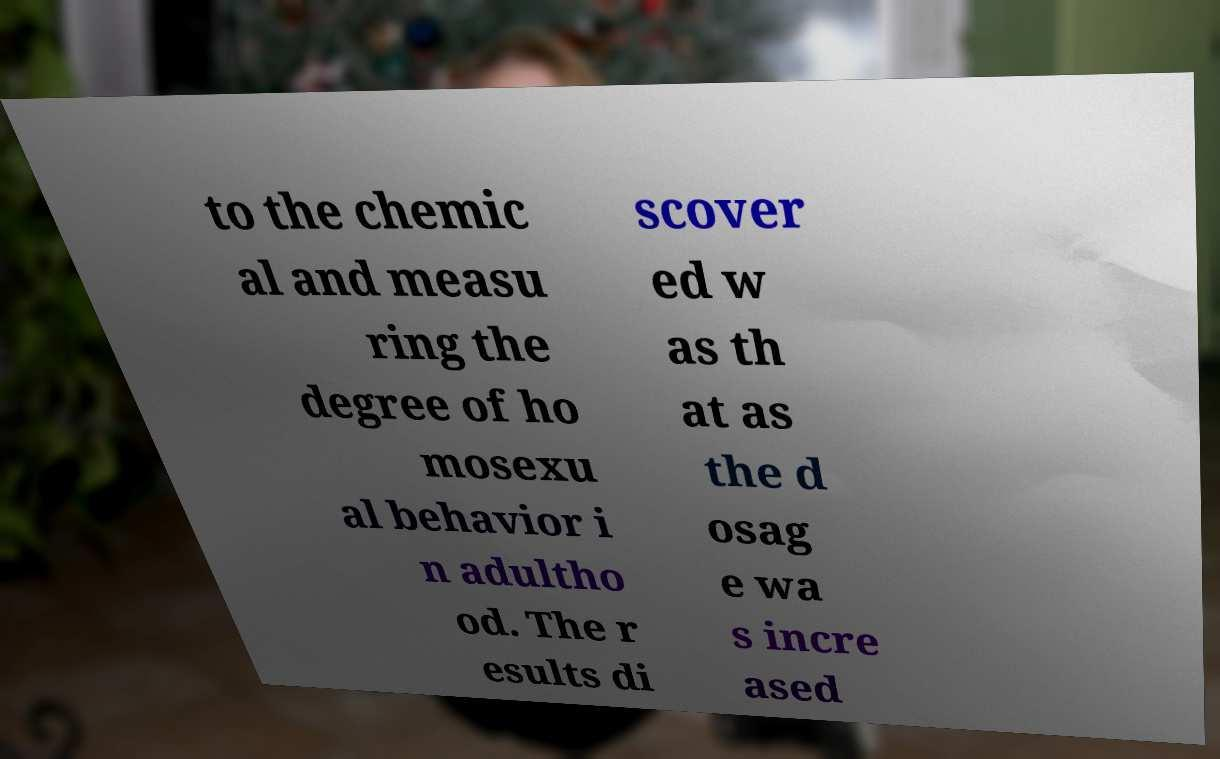Can you accurately transcribe the text from the provided image for me? to the chemic al and measu ring the degree of ho mosexu al behavior i n adultho od. The r esults di scover ed w as th at as the d osag e wa s incre ased 